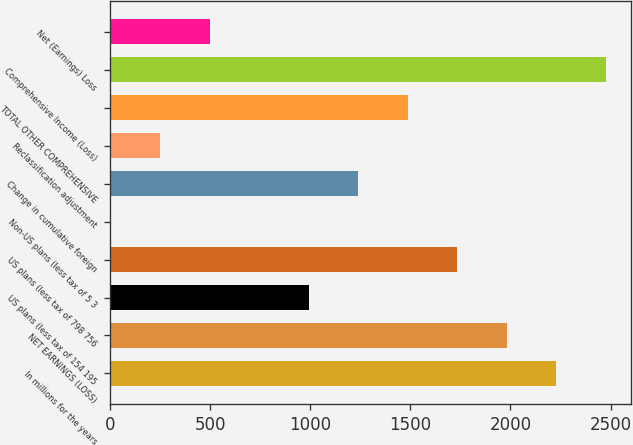Convert chart. <chart><loc_0><loc_0><loc_500><loc_500><bar_chart><fcel>In millions for the years<fcel>NET EARNINGS (LOSS)<fcel>US plans (less tax of 154 195<fcel>US plans (less tax of 798 756<fcel>Non-US plans (less tax of 5 3<fcel>Change in cumulative foreign<fcel>Reclassification adjustment<fcel>TOTAL OTHER COMPREHENSIVE<fcel>Comprehensive Income (Loss)<fcel>Net (Earnings) Loss<nl><fcel>2228.8<fcel>1981.6<fcel>992.8<fcel>1734.4<fcel>4<fcel>1240<fcel>251.2<fcel>1487.2<fcel>2476<fcel>498.4<nl></chart> 